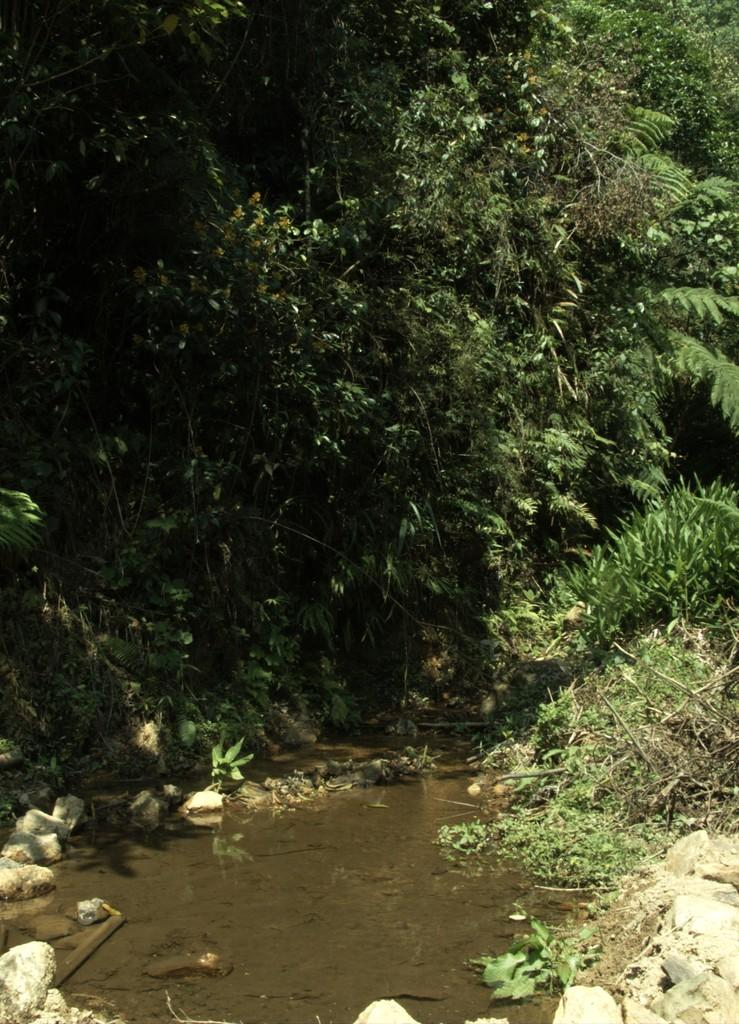What is located in the foreground of the image? There is a water body, stones, and plants in the foreground of the image. Can you describe the terrain in the foreground of the image? The terrain in the foreground of the image includes a water body, stones, and plants. What can be seen at the top of the image? There are trees visible at the top of the image. What decision is being made by the wheel in the image? There is no wheel present in the image, so no decision can be made by a wheel. What theory is being proposed by the plants in the image? There is no theory being proposed by the plants in the image; they are simply part of the terrain. 